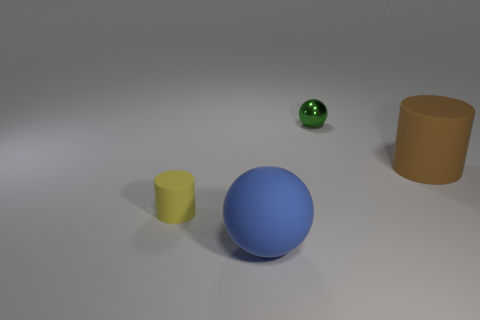Add 1 shiny objects. How many objects exist? 5 Add 1 big cyan metal balls. How many big cyan metal balls exist? 1 Subtract 1 green balls. How many objects are left? 3 Subtract all large cyan objects. Subtract all rubber things. How many objects are left? 1 Add 1 large brown objects. How many large brown objects are left? 2 